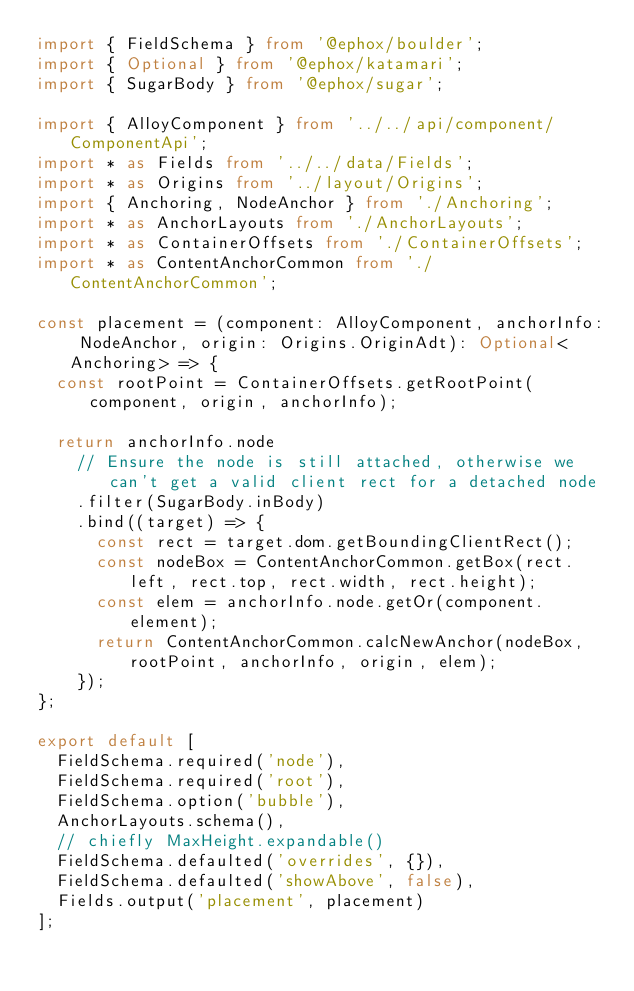<code> <loc_0><loc_0><loc_500><loc_500><_TypeScript_>import { FieldSchema } from '@ephox/boulder';
import { Optional } from '@ephox/katamari';
import { SugarBody } from '@ephox/sugar';

import { AlloyComponent } from '../../api/component/ComponentApi';
import * as Fields from '../../data/Fields';
import * as Origins from '../layout/Origins';
import { Anchoring, NodeAnchor } from './Anchoring';
import * as AnchorLayouts from './AnchorLayouts';
import * as ContainerOffsets from './ContainerOffsets';
import * as ContentAnchorCommon from './ContentAnchorCommon';

const placement = (component: AlloyComponent, anchorInfo: NodeAnchor, origin: Origins.OriginAdt): Optional<Anchoring> => {
  const rootPoint = ContainerOffsets.getRootPoint(component, origin, anchorInfo);

  return anchorInfo.node
    // Ensure the node is still attached, otherwise we can't get a valid client rect for a detached node
    .filter(SugarBody.inBody)
    .bind((target) => {
      const rect = target.dom.getBoundingClientRect();
      const nodeBox = ContentAnchorCommon.getBox(rect.left, rect.top, rect.width, rect.height);
      const elem = anchorInfo.node.getOr(component.element);
      return ContentAnchorCommon.calcNewAnchor(nodeBox, rootPoint, anchorInfo, origin, elem);
    });
};

export default [
  FieldSchema.required('node'),
  FieldSchema.required('root'),
  FieldSchema.option('bubble'),
  AnchorLayouts.schema(),
  // chiefly MaxHeight.expandable()
  FieldSchema.defaulted('overrides', {}),
  FieldSchema.defaulted('showAbove', false),
  Fields.output('placement', placement)
];
</code> 